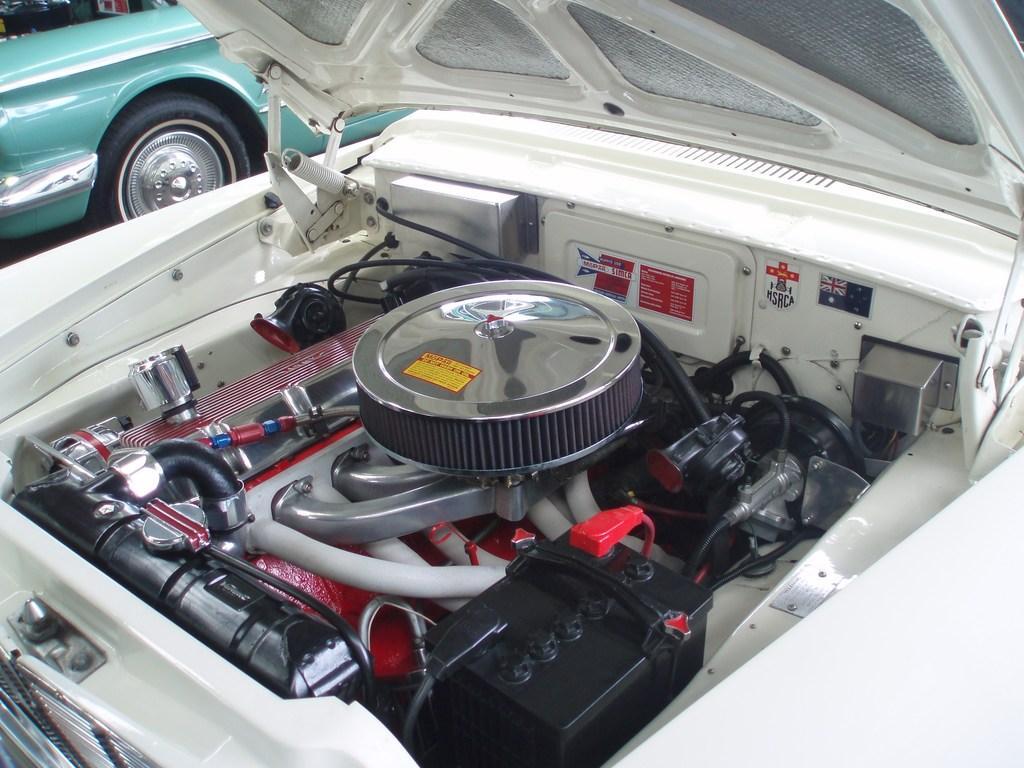Please provide a concise description of this image. In this picture we can see vehicles and vehicle parts. 